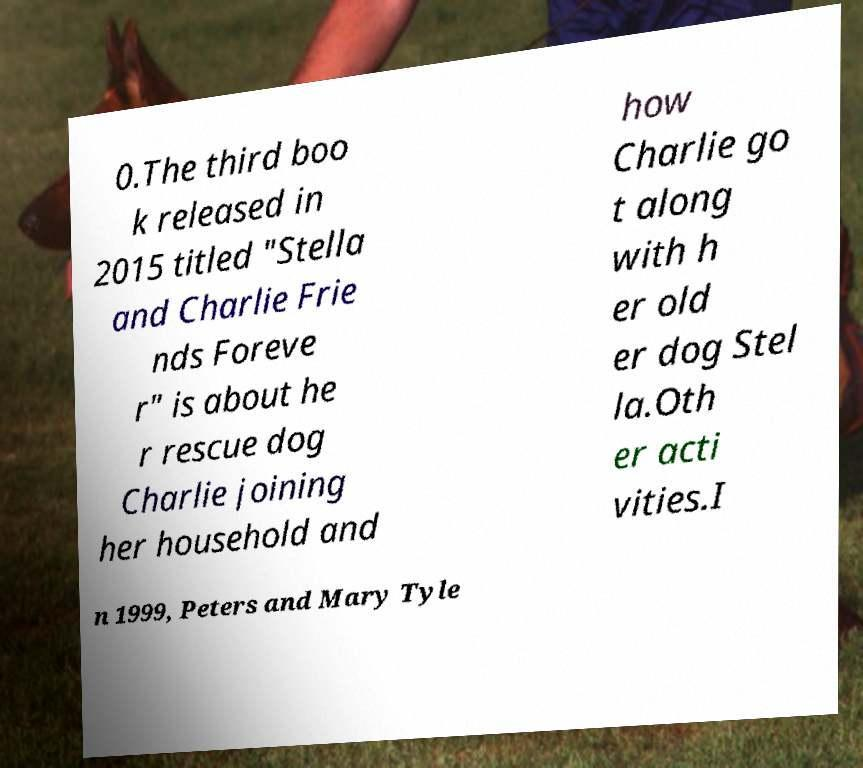What messages or text are displayed in this image? I need them in a readable, typed format. 0.The third boo k released in 2015 titled "Stella and Charlie Frie nds Foreve r" is about he r rescue dog Charlie joining her household and how Charlie go t along with h er old er dog Stel la.Oth er acti vities.I n 1999, Peters and Mary Tyle 